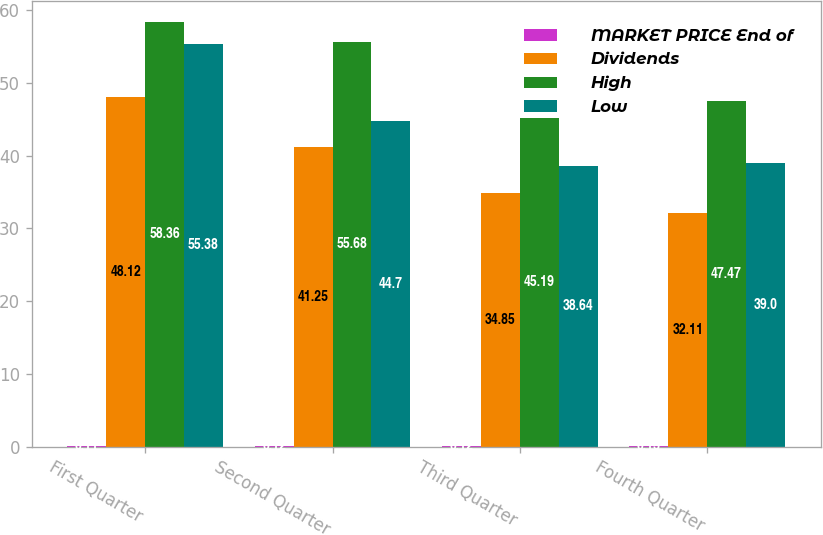Convert chart. <chart><loc_0><loc_0><loc_500><loc_500><stacked_bar_chart><ecel><fcel>First Quarter<fcel>Second Quarter<fcel>Third Quarter<fcel>Fourth Quarter<nl><fcel>MARKET PRICE End of<fcel>0.11<fcel>0.12<fcel>0.12<fcel>0.13<nl><fcel>Dividends<fcel>48.12<fcel>41.25<fcel>34.85<fcel>32.11<nl><fcel>High<fcel>58.36<fcel>55.68<fcel>45.19<fcel>47.47<nl><fcel>Low<fcel>55.38<fcel>44.7<fcel>38.64<fcel>39<nl></chart> 